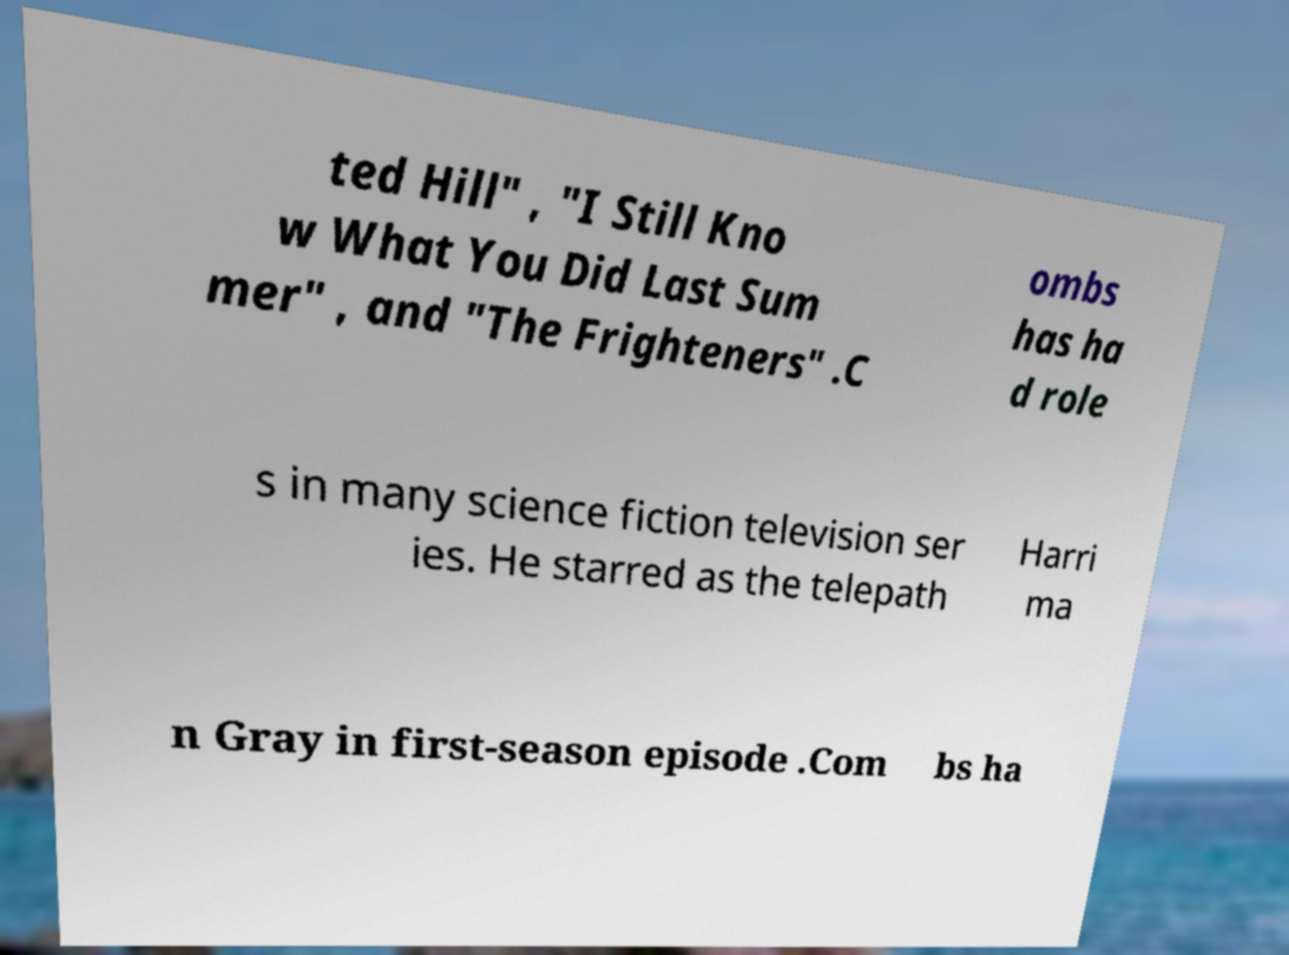For documentation purposes, I need the text within this image transcribed. Could you provide that? ted Hill" , "I Still Kno w What You Did Last Sum mer" , and "The Frighteners" .C ombs has ha d role s in many science fiction television ser ies. He starred as the telepath Harri ma n Gray in first-season episode .Com bs ha 